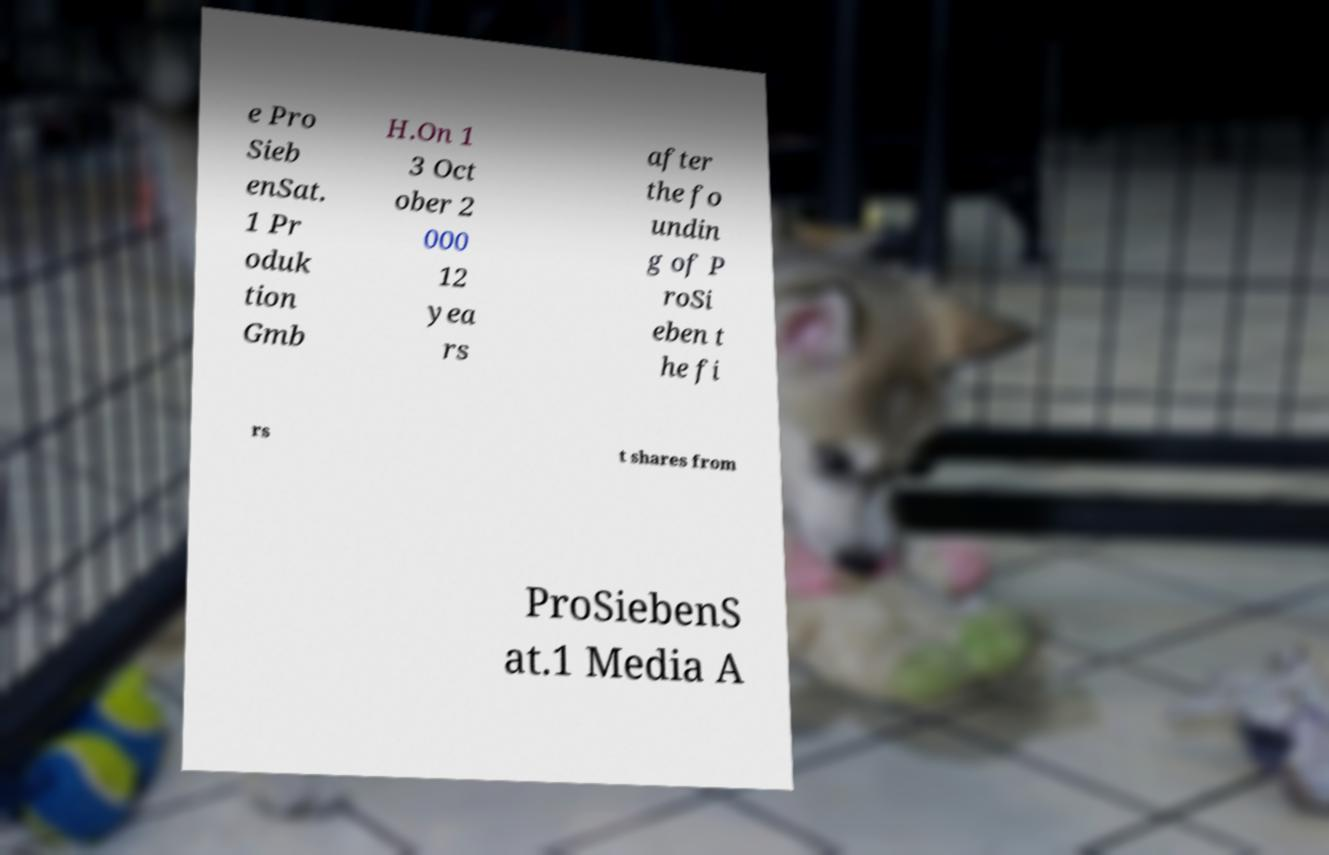Can you accurately transcribe the text from the provided image for me? e Pro Sieb enSat. 1 Pr oduk tion Gmb H.On 1 3 Oct ober 2 000 12 yea rs after the fo undin g of P roSi eben t he fi rs t shares from ProSiebenS at.1 Media A 